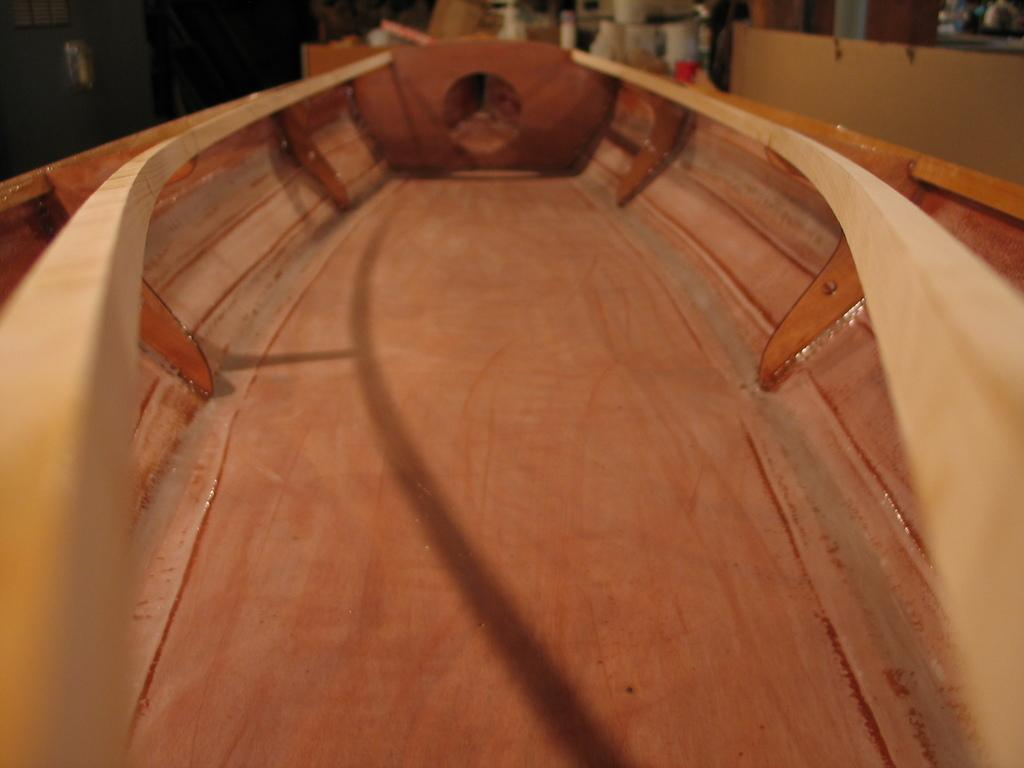What is the main subject of the image? There is a boat in the center of the image. What type of twig is being used to attack the boat in the image? There is no twig or attack present in the image; it only features a boat. What is the shape of the nose of the person driving the boat in the image? There is no person or nose visible in the image; it only features a boat. 